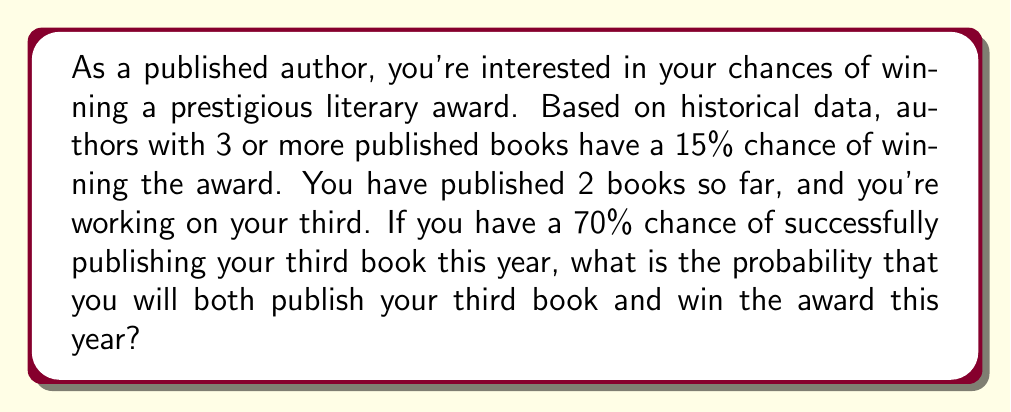Provide a solution to this math problem. To solve this problem, we need to use the concept of conditional probability and the multiplication rule of probability. Let's break it down step by step:

1) Let's define our events:
   A: Successfully publishing the third book
   B: Winning the award (given that you have published 3 or more books)

2) We're given the following probabilities:
   $P(A) = 0.70$ (70% chance of publishing the third book)
   $P(B|A) = 0.15$ (15% chance of winning the award, given that you have 3 or more published books)

3) We want to find the probability of both events occurring: $P(A \text{ and } B)$

4) The multiplication rule of probability states:
   $P(A \text{ and } B) = P(A) \cdot P(B|A)$

5) Substituting our values:
   $P(A \text{ and } B) = 0.70 \cdot 0.15$

6) Calculating:
   $P(A \text{ and } B) = 0.105 = 10.5\%$

Therefore, the probability of both publishing your third book and winning the award this year is 10.5%.
Answer: The probability is 0.105 or 10.5%. 